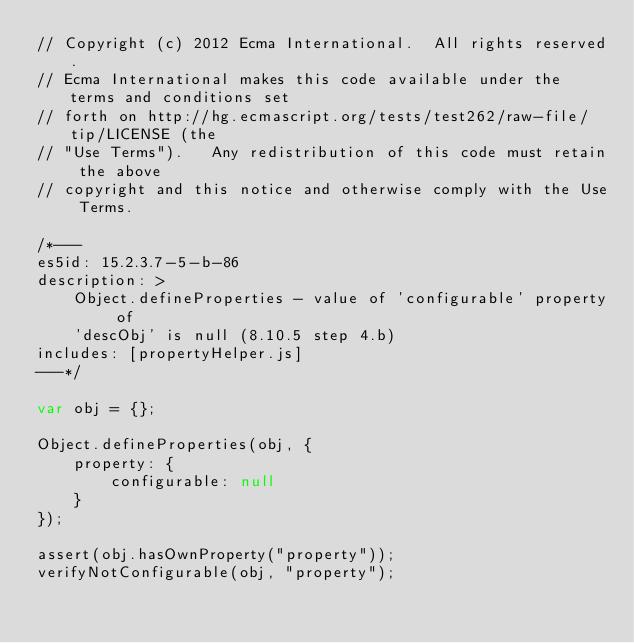Convert code to text. <code><loc_0><loc_0><loc_500><loc_500><_JavaScript_>// Copyright (c) 2012 Ecma International.  All rights reserved.
// Ecma International makes this code available under the terms and conditions set
// forth on http://hg.ecmascript.org/tests/test262/raw-file/tip/LICENSE (the
// "Use Terms").   Any redistribution of this code must retain the above
// copyright and this notice and otherwise comply with the Use Terms.

/*---
es5id: 15.2.3.7-5-b-86
description: >
    Object.defineProperties - value of 'configurable' property of
    'descObj' is null (8.10.5 step 4.b)
includes: [propertyHelper.js]
---*/

var obj = {};

Object.defineProperties(obj, {
    property: {
        configurable: null
    }
});

assert(obj.hasOwnProperty("property"));
verifyNotConfigurable(obj, "property");
</code> 